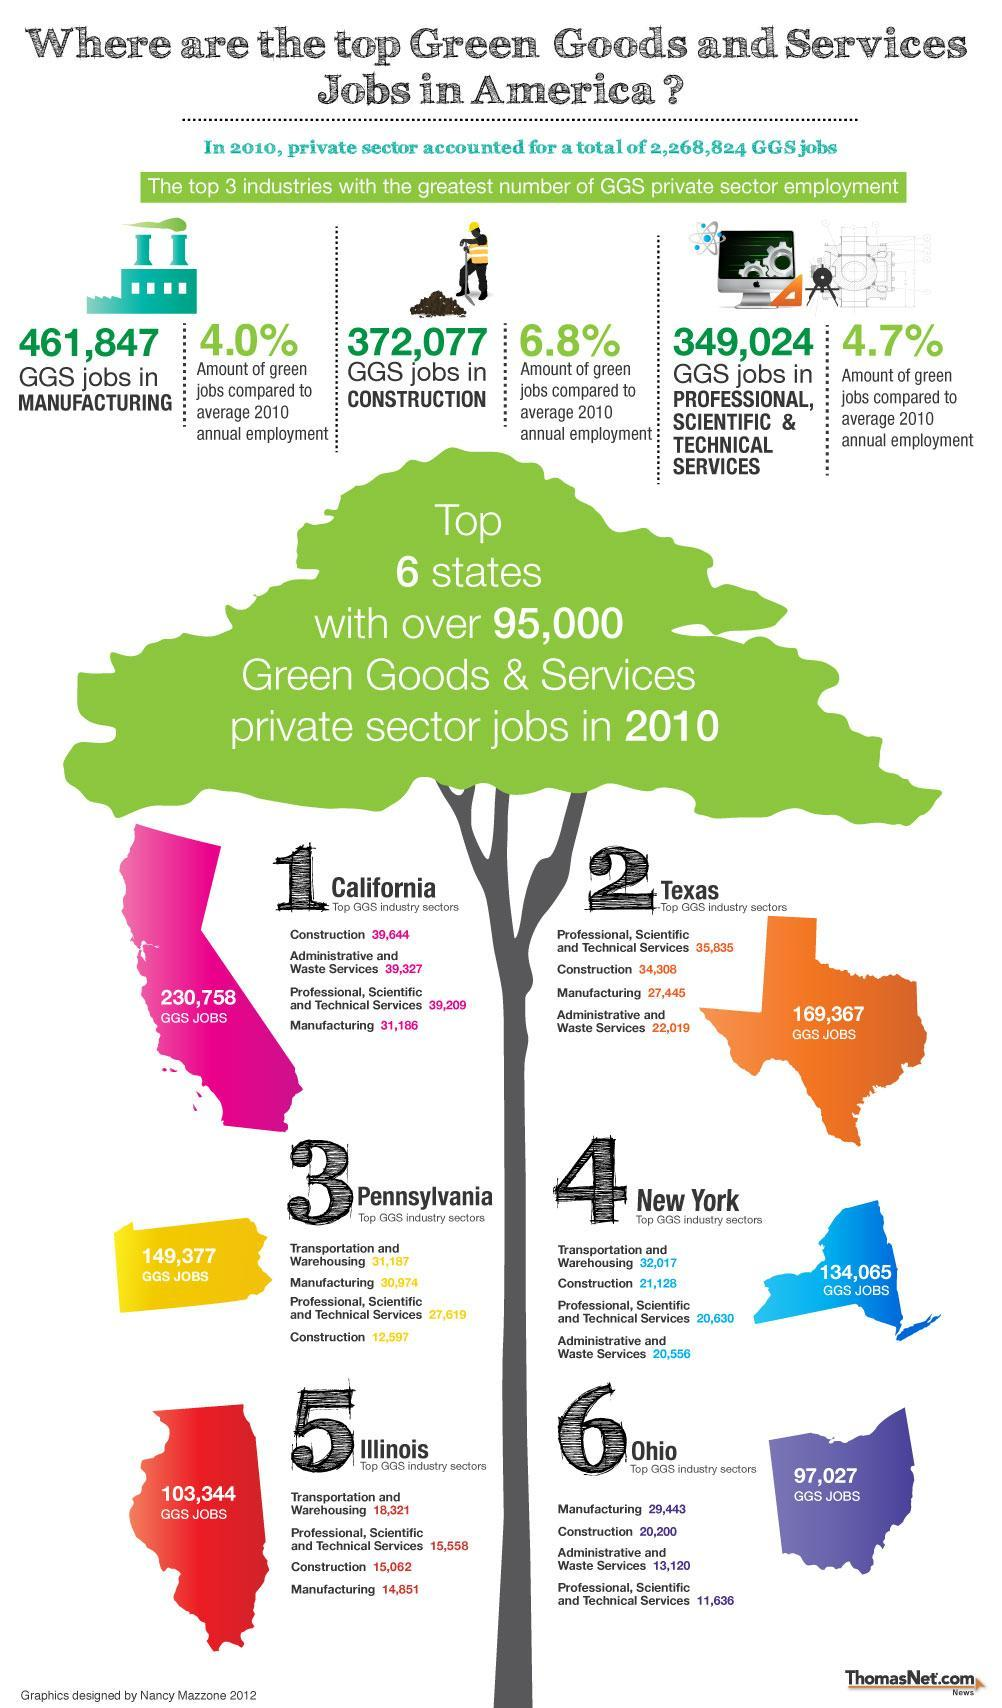Which state has 103,344 GGS jobs
Answer the question with a short phrase. Illinois Which state is represented in red colour Illinois What state is represented in blue colour New York Which state has 230,758 GGS jobs California What is the total number of GGS jobs in Texas 169,367 What is the total GGS jobs in construction and manufacturing 833924 What is the total count of transportation and warehousing jobs in Pennsylvania and Illinois 49508 